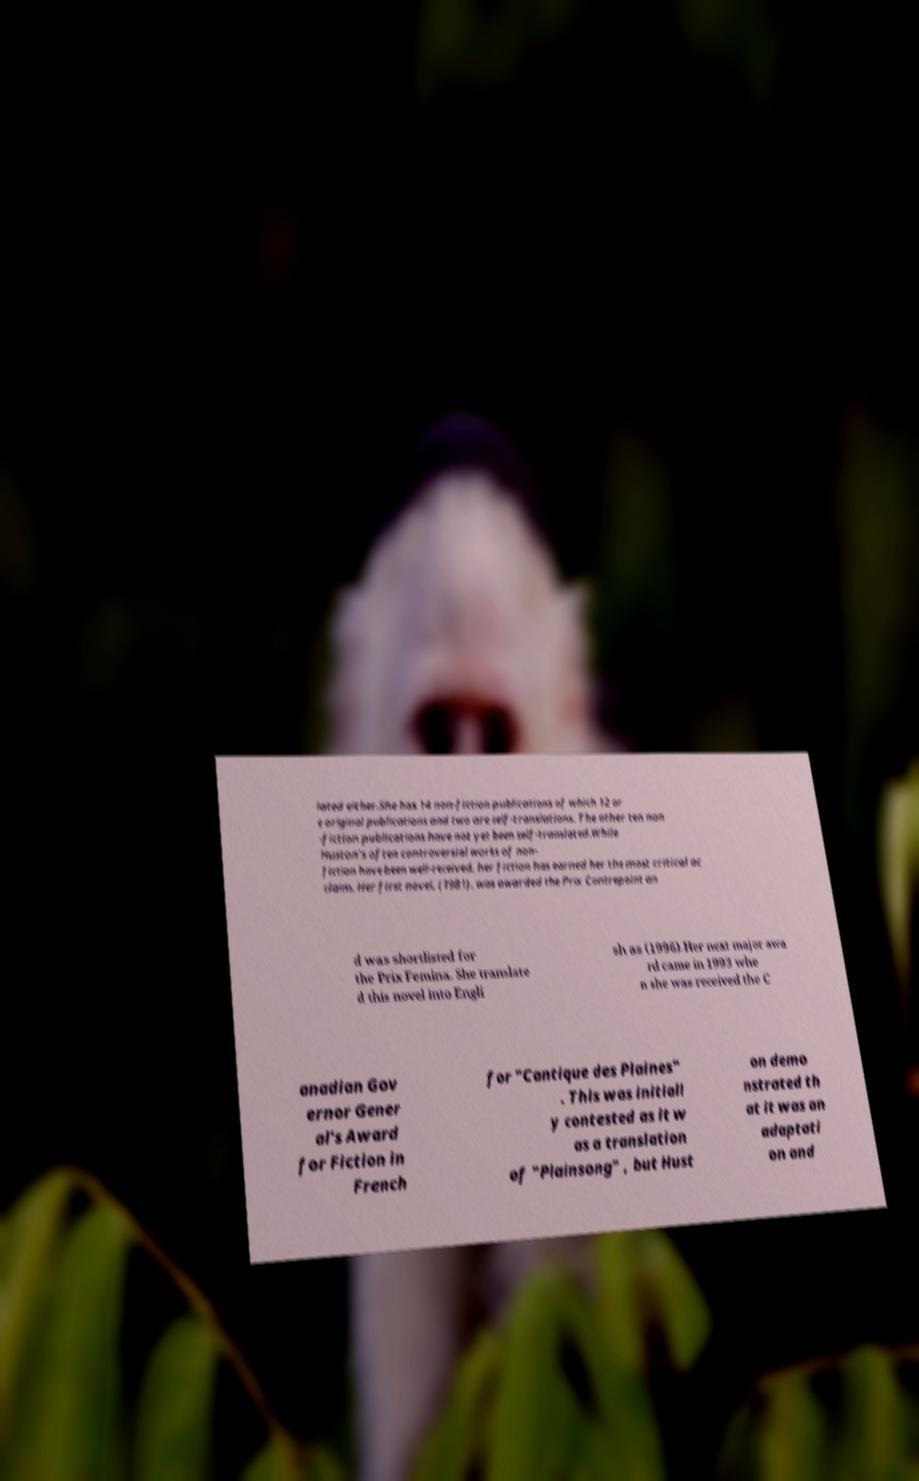Please read and relay the text visible in this image. What does it say? lated either.She has 14 non-fiction publications of which 12 ar e original publications and two are self-translations. The other ten non -fiction publications have not yet been self-translated.While Huston's often controversial works of non- fiction have been well-received, her fiction has earned her the most critical ac claim. Her first novel, (1981), was awarded the Prix Contrepoint an d was shortlisted for the Prix Femina. She translate d this novel into Engli sh as (1996).Her next major awa rd came in 1993 whe n she was received the C anadian Gov ernor Gener al's Award for Fiction in French for "Cantique des Plaines" . This was initiall y contested as it w as a translation of "Plainsong" , but Hust on demo nstrated th at it was an adaptati on and 